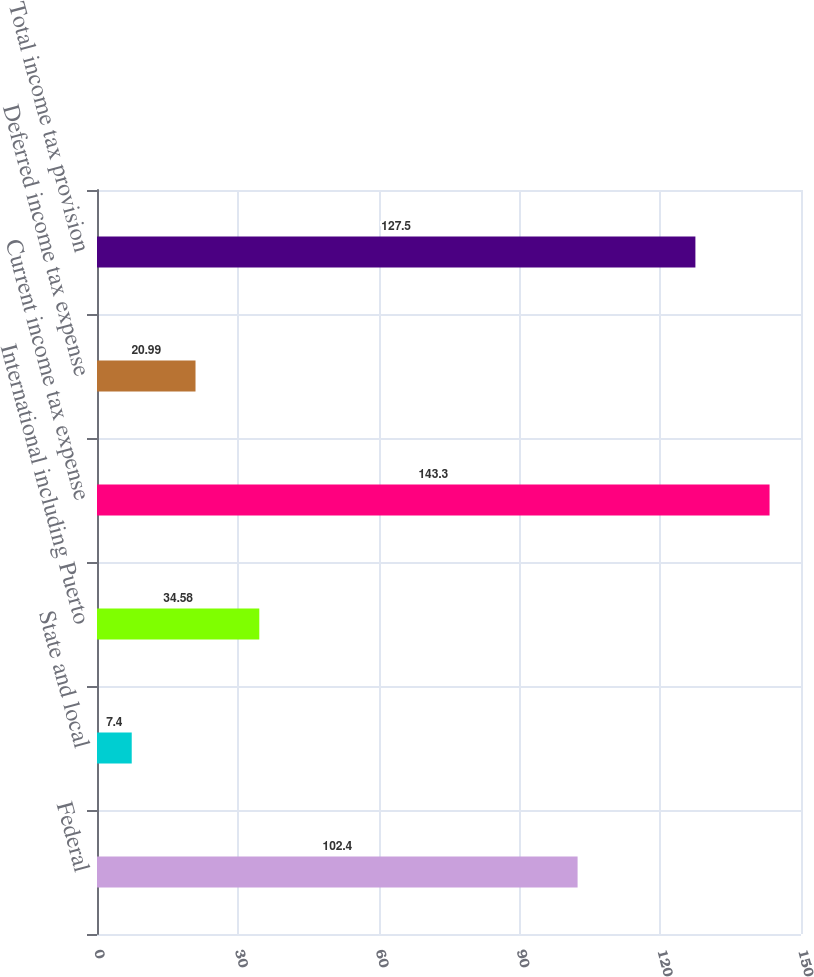Convert chart to OTSL. <chart><loc_0><loc_0><loc_500><loc_500><bar_chart><fcel>Federal<fcel>State and local<fcel>International including Puerto<fcel>Current income tax expense<fcel>Deferred income tax expense<fcel>Total income tax provision<nl><fcel>102.4<fcel>7.4<fcel>34.58<fcel>143.3<fcel>20.99<fcel>127.5<nl></chart> 